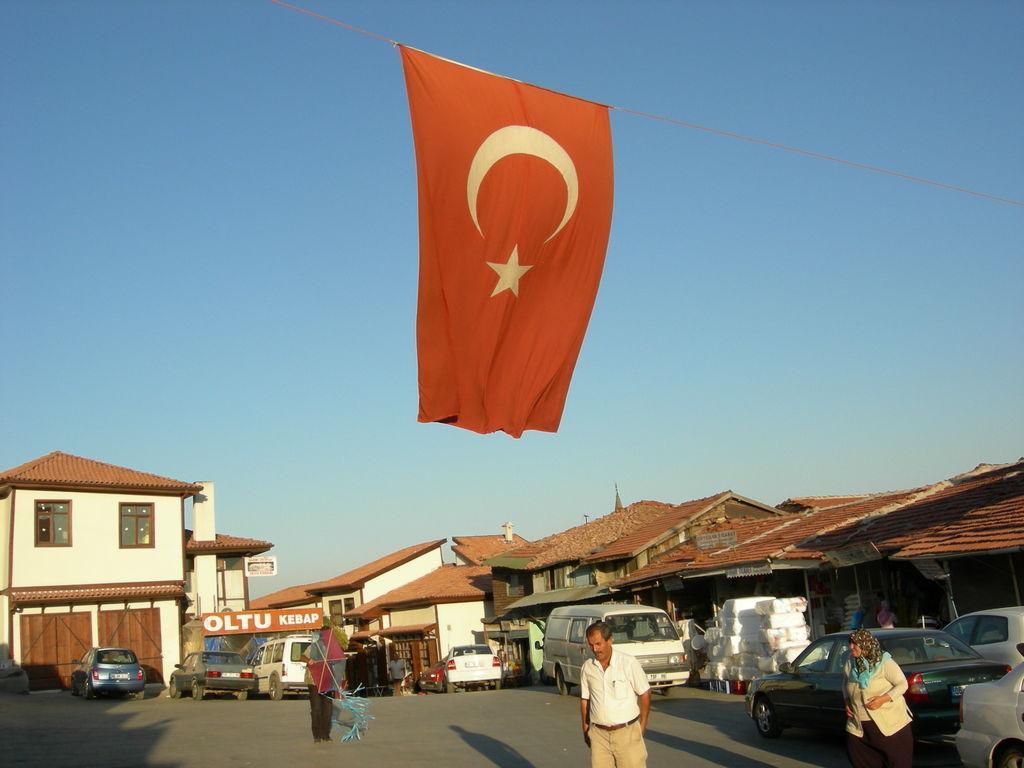Please provide a concise description of this image. In this picture there are people and we can see vehicles on the road, houses, flag on rope, boards and objects. In the background of the image we can see the sky. 